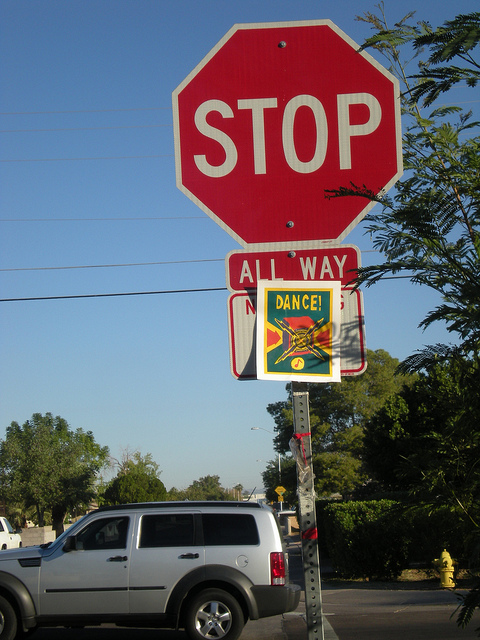<image>What country flag is hanging? There is no flag hanging in the image. Is that gray truck a Chevy or a Dodge? It is unknown if the gray truck is a Chevy or a Dodge. It could be either. What is on the back of this sign? It is unknown what is on the back of the sign. It could be a stop sign, a flyer, more signs, paper, a tree or metal. What country flag is hanging? It is unknown what country flag is hanging. There is no flag visible in the image. Is that gray truck a Chevy or a Dodge? I don't know if that gray truck is a Chevy or a Dodge. It seems to be a Dodge but I am not sure. What is on the back of this sign? It is unknown what is on the back of the sign. It can be seen as 'stop sign', 'flyer', 'more signs', 'paper', 'tree' or 'metal'. 